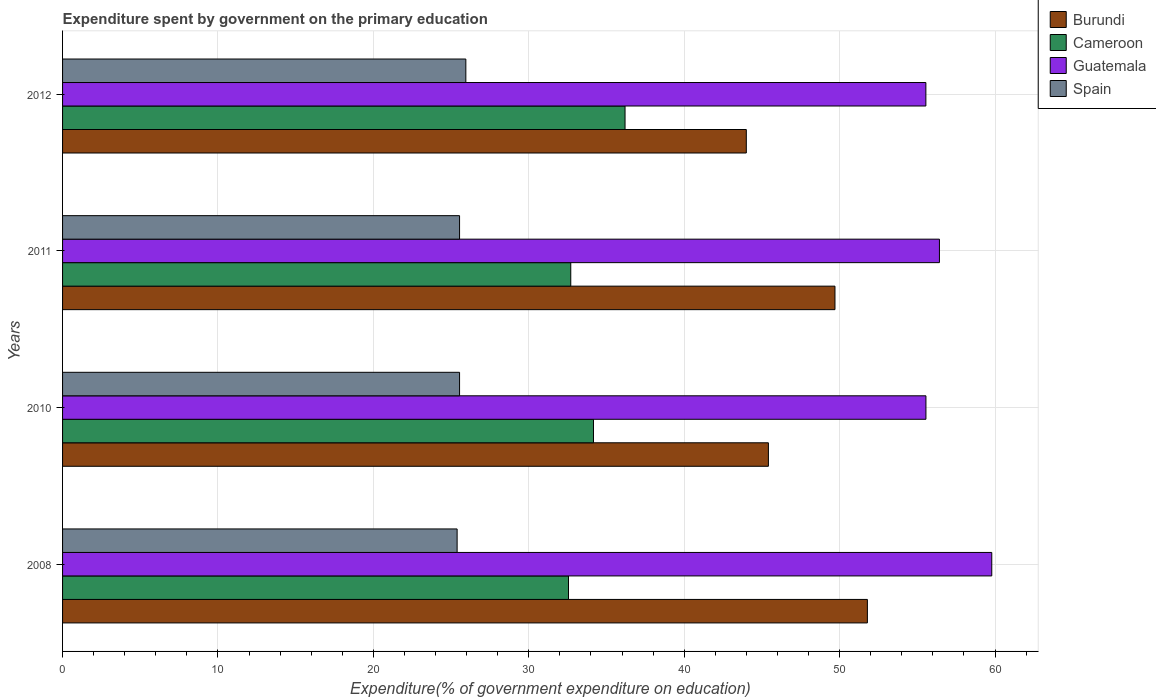How many different coloured bars are there?
Ensure brevity in your answer.  4. Are the number of bars per tick equal to the number of legend labels?
Make the answer very short. Yes. Are the number of bars on each tick of the Y-axis equal?
Ensure brevity in your answer.  Yes. How many bars are there on the 3rd tick from the bottom?
Provide a short and direct response. 4. What is the label of the 4th group of bars from the top?
Provide a succinct answer. 2008. What is the expenditure spent by government on the primary education in Guatemala in 2011?
Make the answer very short. 56.42. Across all years, what is the maximum expenditure spent by government on the primary education in Guatemala?
Keep it short and to the point. 59.79. Across all years, what is the minimum expenditure spent by government on the primary education in Burundi?
Provide a succinct answer. 44. In which year was the expenditure spent by government on the primary education in Cameroon maximum?
Ensure brevity in your answer.  2012. What is the total expenditure spent by government on the primary education in Guatemala in the graph?
Provide a succinct answer. 227.32. What is the difference between the expenditure spent by government on the primary education in Spain in 2011 and that in 2012?
Make the answer very short. -0.4. What is the difference between the expenditure spent by government on the primary education in Guatemala in 2011 and the expenditure spent by government on the primary education in Burundi in 2008?
Your answer should be compact. 4.64. What is the average expenditure spent by government on the primary education in Spain per year?
Your answer should be compact. 25.61. In the year 2011, what is the difference between the expenditure spent by government on the primary education in Burundi and expenditure spent by government on the primary education in Spain?
Your answer should be compact. 24.16. In how many years, is the expenditure spent by government on the primary education in Spain greater than 22 %?
Your answer should be very brief. 4. What is the ratio of the expenditure spent by government on the primary education in Guatemala in 2011 to that in 2012?
Make the answer very short. 1.02. What is the difference between the highest and the second highest expenditure spent by government on the primary education in Guatemala?
Keep it short and to the point. 3.37. What is the difference between the highest and the lowest expenditure spent by government on the primary education in Guatemala?
Keep it short and to the point. 4.24. Is it the case that in every year, the sum of the expenditure spent by government on the primary education in Cameroon and expenditure spent by government on the primary education in Guatemala is greater than the sum of expenditure spent by government on the primary education in Spain and expenditure spent by government on the primary education in Burundi?
Provide a succinct answer. Yes. What does the 1st bar from the top in 2010 represents?
Offer a very short reply. Spain. What does the 3rd bar from the bottom in 2011 represents?
Your answer should be very brief. Guatemala. What is the difference between two consecutive major ticks on the X-axis?
Your answer should be very brief. 10. Are the values on the major ticks of X-axis written in scientific E-notation?
Keep it short and to the point. No. Where does the legend appear in the graph?
Your response must be concise. Top right. How many legend labels are there?
Provide a short and direct response. 4. What is the title of the graph?
Provide a short and direct response. Expenditure spent by government on the primary education. Does "Virgin Islands" appear as one of the legend labels in the graph?
Your answer should be compact. No. What is the label or title of the X-axis?
Provide a short and direct response. Expenditure(% of government expenditure on education). What is the Expenditure(% of government expenditure on education) in Burundi in 2008?
Keep it short and to the point. 51.79. What is the Expenditure(% of government expenditure on education) of Cameroon in 2008?
Offer a very short reply. 32.55. What is the Expenditure(% of government expenditure on education) of Guatemala in 2008?
Your answer should be compact. 59.79. What is the Expenditure(% of government expenditure on education) in Spain in 2008?
Your response must be concise. 25.39. What is the Expenditure(% of government expenditure on education) of Burundi in 2010?
Your answer should be compact. 45.42. What is the Expenditure(% of government expenditure on education) of Cameroon in 2010?
Your answer should be very brief. 34.16. What is the Expenditure(% of government expenditure on education) of Guatemala in 2010?
Provide a succinct answer. 55.55. What is the Expenditure(% of government expenditure on education) in Spain in 2010?
Your response must be concise. 25.54. What is the Expenditure(% of government expenditure on education) of Burundi in 2011?
Your answer should be very brief. 49.7. What is the Expenditure(% of government expenditure on education) in Cameroon in 2011?
Your answer should be very brief. 32.7. What is the Expenditure(% of government expenditure on education) in Guatemala in 2011?
Offer a terse response. 56.42. What is the Expenditure(% of government expenditure on education) in Spain in 2011?
Ensure brevity in your answer.  25.54. What is the Expenditure(% of government expenditure on education) in Burundi in 2012?
Give a very brief answer. 44. What is the Expenditure(% of government expenditure on education) of Cameroon in 2012?
Give a very brief answer. 36.19. What is the Expenditure(% of government expenditure on education) of Guatemala in 2012?
Your answer should be compact. 55.55. What is the Expenditure(% of government expenditure on education) of Spain in 2012?
Your answer should be compact. 25.95. Across all years, what is the maximum Expenditure(% of government expenditure on education) of Burundi?
Provide a short and direct response. 51.79. Across all years, what is the maximum Expenditure(% of government expenditure on education) of Cameroon?
Your answer should be compact. 36.19. Across all years, what is the maximum Expenditure(% of government expenditure on education) of Guatemala?
Provide a succinct answer. 59.79. Across all years, what is the maximum Expenditure(% of government expenditure on education) in Spain?
Your answer should be very brief. 25.95. Across all years, what is the minimum Expenditure(% of government expenditure on education) in Burundi?
Make the answer very short. 44. Across all years, what is the minimum Expenditure(% of government expenditure on education) in Cameroon?
Make the answer very short. 32.55. Across all years, what is the minimum Expenditure(% of government expenditure on education) in Guatemala?
Provide a succinct answer. 55.55. Across all years, what is the minimum Expenditure(% of government expenditure on education) in Spain?
Provide a short and direct response. 25.39. What is the total Expenditure(% of government expenditure on education) of Burundi in the graph?
Give a very brief answer. 190.9. What is the total Expenditure(% of government expenditure on education) in Cameroon in the graph?
Offer a terse response. 135.61. What is the total Expenditure(% of government expenditure on education) of Guatemala in the graph?
Make the answer very short. 227.32. What is the total Expenditure(% of government expenditure on education) in Spain in the graph?
Your answer should be compact. 102.43. What is the difference between the Expenditure(% of government expenditure on education) in Burundi in 2008 and that in 2010?
Give a very brief answer. 6.37. What is the difference between the Expenditure(% of government expenditure on education) in Cameroon in 2008 and that in 2010?
Make the answer very short. -1.61. What is the difference between the Expenditure(% of government expenditure on education) of Guatemala in 2008 and that in 2010?
Your response must be concise. 4.24. What is the difference between the Expenditure(% of government expenditure on education) of Spain in 2008 and that in 2010?
Your answer should be very brief. -0.16. What is the difference between the Expenditure(% of government expenditure on education) of Burundi in 2008 and that in 2011?
Make the answer very short. 2.09. What is the difference between the Expenditure(% of government expenditure on education) of Cameroon in 2008 and that in 2011?
Keep it short and to the point. -0.15. What is the difference between the Expenditure(% of government expenditure on education) of Guatemala in 2008 and that in 2011?
Provide a short and direct response. 3.37. What is the difference between the Expenditure(% of government expenditure on education) of Spain in 2008 and that in 2011?
Your response must be concise. -0.16. What is the difference between the Expenditure(% of government expenditure on education) of Burundi in 2008 and that in 2012?
Your response must be concise. 7.79. What is the difference between the Expenditure(% of government expenditure on education) in Cameroon in 2008 and that in 2012?
Your answer should be compact. -3.64. What is the difference between the Expenditure(% of government expenditure on education) in Guatemala in 2008 and that in 2012?
Your response must be concise. 4.24. What is the difference between the Expenditure(% of government expenditure on education) of Spain in 2008 and that in 2012?
Your answer should be compact. -0.56. What is the difference between the Expenditure(% of government expenditure on education) of Burundi in 2010 and that in 2011?
Offer a very short reply. -4.28. What is the difference between the Expenditure(% of government expenditure on education) in Cameroon in 2010 and that in 2011?
Give a very brief answer. 1.46. What is the difference between the Expenditure(% of government expenditure on education) of Guatemala in 2010 and that in 2011?
Offer a terse response. -0.87. What is the difference between the Expenditure(% of government expenditure on education) in Spain in 2010 and that in 2011?
Ensure brevity in your answer.  0. What is the difference between the Expenditure(% of government expenditure on education) of Burundi in 2010 and that in 2012?
Your response must be concise. 1.42. What is the difference between the Expenditure(% of government expenditure on education) in Cameroon in 2010 and that in 2012?
Your answer should be very brief. -2.03. What is the difference between the Expenditure(% of government expenditure on education) of Guatemala in 2010 and that in 2012?
Your answer should be compact. 0. What is the difference between the Expenditure(% of government expenditure on education) of Spain in 2010 and that in 2012?
Ensure brevity in your answer.  -0.4. What is the difference between the Expenditure(% of government expenditure on education) of Burundi in 2011 and that in 2012?
Offer a terse response. 5.7. What is the difference between the Expenditure(% of government expenditure on education) of Cameroon in 2011 and that in 2012?
Make the answer very short. -3.49. What is the difference between the Expenditure(% of government expenditure on education) in Guatemala in 2011 and that in 2012?
Provide a succinct answer. 0.87. What is the difference between the Expenditure(% of government expenditure on education) of Spain in 2011 and that in 2012?
Your response must be concise. -0.4. What is the difference between the Expenditure(% of government expenditure on education) in Burundi in 2008 and the Expenditure(% of government expenditure on education) in Cameroon in 2010?
Offer a very short reply. 17.63. What is the difference between the Expenditure(% of government expenditure on education) of Burundi in 2008 and the Expenditure(% of government expenditure on education) of Guatemala in 2010?
Offer a terse response. -3.77. What is the difference between the Expenditure(% of government expenditure on education) of Burundi in 2008 and the Expenditure(% of government expenditure on education) of Spain in 2010?
Your answer should be very brief. 26.24. What is the difference between the Expenditure(% of government expenditure on education) of Cameroon in 2008 and the Expenditure(% of government expenditure on education) of Guatemala in 2010?
Your answer should be compact. -23. What is the difference between the Expenditure(% of government expenditure on education) of Cameroon in 2008 and the Expenditure(% of government expenditure on education) of Spain in 2010?
Make the answer very short. 7.01. What is the difference between the Expenditure(% of government expenditure on education) in Guatemala in 2008 and the Expenditure(% of government expenditure on education) in Spain in 2010?
Provide a succinct answer. 34.25. What is the difference between the Expenditure(% of government expenditure on education) of Burundi in 2008 and the Expenditure(% of government expenditure on education) of Cameroon in 2011?
Your answer should be very brief. 19.09. What is the difference between the Expenditure(% of government expenditure on education) in Burundi in 2008 and the Expenditure(% of government expenditure on education) in Guatemala in 2011?
Make the answer very short. -4.64. What is the difference between the Expenditure(% of government expenditure on education) of Burundi in 2008 and the Expenditure(% of government expenditure on education) of Spain in 2011?
Your answer should be compact. 26.24. What is the difference between the Expenditure(% of government expenditure on education) of Cameroon in 2008 and the Expenditure(% of government expenditure on education) of Guatemala in 2011?
Your response must be concise. -23.87. What is the difference between the Expenditure(% of government expenditure on education) in Cameroon in 2008 and the Expenditure(% of government expenditure on education) in Spain in 2011?
Provide a short and direct response. 7.01. What is the difference between the Expenditure(% of government expenditure on education) in Guatemala in 2008 and the Expenditure(% of government expenditure on education) in Spain in 2011?
Ensure brevity in your answer.  34.25. What is the difference between the Expenditure(% of government expenditure on education) of Burundi in 2008 and the Expenditure(% of government expenditure on education) of Cameroon in 2012?
Make the answer very short. 15.59. What is the difference between the Expenditure(% of government expenditure on education) of Burundi in 2008 and the Expenditure(% of government expenditure on education) of Guatemala in 2012?
Your answer should be very brief. -3.76. What is the difference between the Expenditure(% of government expenditure on education) of Burundi in 2008 and the Expenditure(% of government expenditure on education) of Spain in 2012?
Provide a short and direct response. 25.84. What is the difference between the Expenditure(% of government expenditure on education) in Cameroon in 2008 and the Expenditure(% of government expenditure on education) in Guatemala in 2012?
Your response must be concise. -23. What is the difference between the Expenditure(% of government expenditure on education) in Cameroon in 2008 and the Expenditure(% of government expenditure on education) in Spain in 2012?
Offer a terse response. 6.61. What is the difference between the Expenditure(% of government expenditure on education) in Guatemala in 2008 and the Expenditure(% of government expenditure on education) in Spain in 2012?
Make the answer very short. 33.84. What is the difference between the Expenditure(% of government expenditure on education) in Burundi in 2010 and the Expenditure(% of government expenditure on education) in Cameroon in 2011?
Your answer should be very brief. 12.72. What is the difference between the Expenditure(% of government expenditure on education) in Burundi in 2010 and the Expenditure(% of government expenditure on education) in Guatemala in 2011?
Ensure brevity in your answer.  -11. What is the difference between the Expenditure(% of government expenditure on education) of Burundi in 2010 and the Expenditure(% of government expenditure on education) of Spain in 2011?
Provide a succinct answer. 19.87. What is the difference between the Expenditure(% of government expenditure on education) in Cameroon in 2010 and the Expenditure(% of government expenditure on education) in Guatemala in 2011?
Provide a succinct answer. -22.26. What is the difference between the Expenditure(% of government expenditure on education) in Cameroon in 2010 and the Expenditure(% of government expenditure on education) in Spain in 2011?
Offer a terse response. 8.62. What is the difference between the Expenditure(% of government expenditure on education) of Guatemala in 2010 and the Expenditure(% of government expenditure on education) of Spain in 2011?
Your response must be concise. 30.01. What is the difference between the Expenditure(% of government expenditure on education) of Burundi in 2010 and the Expenditure(% of government expenditure on education) of Cameroon in 2012?
Keep it short and to the point. 9.22. What is the difference between the Expenditure(% of government expenditure on education) of Burundi in 2010 and the Expenditure(% of government expenditure on education) of Guatemala in 2012?
Ensure brevity in your answer.  -10.13. What is the difference between the Expenditure(% of government expenditure on education) of Burundi in 2010 and the Expenditure(% of government expenditure on education) of Spain in 2012?
Ensure brevity in your answer.  19.47. What is the difference between the Expenditure(% of government expenditure on education) in Cameroon in 2010 and the Expenditure(% of government expenditure on education) in Guatemala in 2012?
Your answer should be very brief. -21.39. What is the difference between the Expenditure(% of government expenditure on education) in Cameroon in 2010 and the Expenditure(% of government expenditure on education) in Spain in 2012?
Offer a terse response. 8.21. What is the difference between the Expenditure(% of government expenditure on education) of Guatemala in 2010 and the Expenditure(% of government expenditure on education) of Spain in 2012?
Keep it short and to the point. 29.6. What is the difference between the Expenditure(% of government expenditure on education) of Burundi in 2011 and the Expenditure(% of government expenditure on education) of Cameroon in 2012?
Provide a short and direct response. 13.51. What is the difference between the Expenditure(% of government expenditure on education) in Burundi in 2011 and the Expenditure(% of government expenditure on education) in Guatemala in 2012?
Your response must be concise. -5.85. What is the difference between the Expenditure(% of government expenditure on education) of Burundi in 2011 and the Expenditure(% of government expenditure on education) of Spain in 2012?
Offer a terse response. 23.75. What is the difference between the Expenditure(% of government expenditure on education) of Cameroon in 2011 and the Expenditure(% of government expenditure on education) of Guatemala in 2012?
Your answer should be compact. -22.85. What is the difference between the Expenditure(% of government expenditure on education) of Cameroon in 2011 and the Expenditure(% of government expenditure on education) of Spain in 2012?
Offer a terse response. 6.75. What is the difference between the Expenditure(% of government expenditure on education) of Guatemala in 2011 and the Expenditure(% of government expenditure on education) of Spain in 2012?
Make the answer very short. 30.47. What is the average Expenditure(% of government expenditure on education) of Burundi per year?
Keep it short and to the point. 47.73. What is the average Expenditure(% of government expenditure on education) of Cameroon per year?
Ensure brevity in your answer.  33.9. What is the average Expenditure(% of government expenditure on education) of Guatemala per year?
Your response must be concise. 56.83. What is the average Expenditure(% of government expenditure on education) in Spain per year?
Ensure brevity in your answer.  25.61. In the year 2008, what is the difference between the Expenditure(% of government expenditure on education) of Burundi and Expenditure(% of government expenditure on education) of Cameroon?
Ensure brevity in your answer.  19.23. In the year 2008, what is the difference between the Expenditure(% of government expenditure on education) of Burundi and Expenditure(% of government expenditure on education) of Guatemala?
Ensure brevity in your answer.  -8. In the year 2008, what is the difference between the Expenditure(% of government expenditure on education) in Burundi and Expenditure(% of government expenditure on education) in Spain?
Offer a very short reply. 26.4. In the year 2008, what is the difference between the Expenditure(% of government expenditure on education) of Cameroon and Expenditure(% of government expenditure on education) of Guatemala?
Provide a succinct answer. -27.24. In the year 2008, what is the difference between the Expenditure(% of government expenditure on education) of Cameroon and Expenditure(% of government expenditure on education) of Spain?
Make the answer very short. 7.17. In the year 2008, what is the difference between the Expenditure(% of government expenditure on education) of Guatemala and Expenditure(% of government expenditure on education) of Spain?
Make the answer very short. 34.4. In the year 2010, what is the difference between the Expenditure(% of government expenditure on education) of Burundi and Expenditure(% of government expenditure on education) of Cameroon?
Your answer should be compact. 11.26. In the year 2010, what is the difference between the Expenditure(% of government expenditure on education) in Burundi and Expenditure(% of government expenditure on education) in Guatemala?
Provide a succinct answer. -10.14. In the year 2010, what is the difference between the Expenditure(% of government expenditure on education) in Burundi and Expenditure(% of government expenditure on education) in Spain?
Make the answer very short. 19.87. In the year 2010, what is the difference between the Expenditure(% of government expenditure on education) of Cameroon and Expenditure(% of government expenditure on education) of Guatemala?
Your answer should be compact. -21.39. In the year 2010, what is the difference between the Expenditure(% of government expenditure on education) in Cameroon and Expenditure(% of government expenditure on education) in Spain?
Keep it short and to the point. 8.62. In the year 2010, what is the difference between the Expenditure(% of government expenditure on education) in Guatemala and Expenditure(% of government expenditure on education) in Spain?
Your answer should be compact. 30.01. In the year 2011, what is the difference between the Expenditure(% of government expenditure on education) of Burundi and Expenditure(% of government expenditure on education) of Cameroon?
Keep it short and to the point. 17. In the year 2011, what is the difference between the Expenditure(% of government expenditure on education) in Burundi and Expenditure(% of government expenditure on education) in Guatemala?
Your response must be concise. -6.72. In the year 2011, what is the difference between the Expenditure(% of government expenditure on education) in Burundi and Expenditure(% of government expenditure on education) in Spain?
Your response must be concise. 24.16. In the year 2011, what is the difference between the Expenditure(% of government expenditure on education) of Cameroon and Expenditure(% of government expenditure on education) of Guatemala?
Keep it short and to the point. -23.72. In the year 2011, what is the difference between the Expenditure(% of government expenditure on education) in Cameroon and Expenditure(% of government expenditure on education) in Spain?
Give a very brief answer. 7.16. In the year 2011, what is the difference between the Expenditure(% of government expenditure on education) in Guatemala and Expenditure(% of government expenditure on education) in Spain?
Keep it short and to the point. 30.88. In the year 2012, what is the difference between the Expenditure(% of government expenditure on education) of Burundi and Expenditure(% of government expenditure on education) of Cameroon?
Provide a short and direct response. 7.8. In the year 2012, what is the difference between the Expenditure(% of government expenditure on education) of Burundi and Expenditure(% of government expenditure on education) of Guatemala?
Offer a terse response. -11.55. In the year 2012, what is the difference between the Expenditure(% of government expenditure on education) in Burundi and Expenditure(% of government expenditure on education) in Spain?
Keep it short and to the point. 18.05. In the year 2012, what is the difference between the Expenditure(% of government expenditure on education) of Cameroon and Expenditure(% of government expenditure on education) of Guatemala?
Give a very brief answer. -19.36. In the year 2012, what is the difference between the Expenditure(% of government expenditure on education) in Cameroon and Expenditure(% of government expenditure on education) in Spain?
Provide a succinct answer. 10.24. In the year 2012, what is the difference between the Expenditure(% of government expenditure on education) in Guatemala and Expenditure(% of government expenditure on education) in Spain?
Give a very brief answer. 29.6. What is the ratio of the Expenditure(% of government expenditure on education) of Burundi in 2008 to that in 2010?
Provide a short and direct response. 1.14. What is the ratio of the Expenditure(% of government expenditure on education) of Cameroon in 2008 to that in 2010?
Provide a short and direct response. 0.95. What is the ratio of the Expenditure(% of government expenditure on education) of Guatemala in 2008 to that in 2010?
Make the answer very short. 1.08. What is the ratio of the Expenditure(% of government expenditure on education) of Spain in 2008 to that in 2010?
Provide a short and direct response. 0.99. What is the ratio of the Expenditure(% of government expenditure on education) in Burundi in 2008 to that in 2011?
Your response must be concise. 1.04. What is the ratio of the Expenditure(% of government expenditure on education) of Cameroon in 2008 to that in 2011?
Your answer should be compact. 1. What is the ratio of the Expenditure(% of government expenditure on education) of Guatemala in 2008 to that in 2011?
Offer a very short reply. 1.06. What is the ratio of the Expenditure(% of government expenditure on education) of Burundi in 2008 to that in 2012?
Offer a terse response. 1.18. What is the ratio of the Expenditure(% of government expenditure on education) in Cameroon in 2008 to that in 2012?
Provide a succinct answer. 0.9. What is the ratio of the Expenditure(% of government expenditure on education) in Guatemala in 2008 to that in 2012?
Give a very brief answer. 1.08. What is the ratio of the Expenditure(% of government expenditure on education) of Spain in 2008 to that in 2012?
Keep it short and to the point. 0.98. What is the ratio of the Expenditure(% of government expenditure on education) of Burundi in 2010 to that in 2011?
Your answer should be very brief. 0.91. What is the ratio of the Expenditure(% of government expenditure on education) of Cameroon in 2010 to that in 2011?
Your answer should be compact. 1.04. What is the ratio of the Expenditure(% of government expenditure on education) in Guatemala in 2010 to that in 2011?
Give a very brief answer. 0.98. What is the ratio of the Expenditure(% of government expenditure on education) in Burundi in 2010 to that in 2012?
Your answer should be very brief. 1.03. What is the ratio of the Expenditure(% of government expenditure on education) of Cameroon in 2010 to that in 2012?
Your answer should be compact. 0.94. What is the ratio of the Expenditure(% of government expenditure on education) in Spain in 2010 to that in 2012?
Make the answer very short. 0.98. What is the ratio of the Expenditure(% of government expenditure on education) in Burundi in 2011 to that in 2012?
Provide a short and direct response. 1.13. What is the ratio of the Expenditure(% of government expenditure on education) in Cameroon in 2011 to that in 2012?
Ensure brevity in your answer.  0.9. What is the ratio of the Expenditure(% of government expenditure on education) in Guatemala in 2011 to that in 2012?
Provide a short and direct response. 1.02. What is the ratio of the Expenditure(% of government expenditure on education) in Spain in 2011 to that in 2012?
Make the answer very short. 0.98. What is the difference between the highest and the second highest Expenditure(% of government expenditure on education) in Burundi?
Make the answer very short. 2.09. What is the difference between the highest and the second highest Expenditure(% of government expenditure on education) in Cameroon?
Offer a very short reply. 2.03. What is the difference between the highest and the second highest Expenditure(% of government expenditure on education) of Guatemala?
Ensure brevity in your answer.  3.37. What is the difference between the highest and the second highest Expenditure(% of government expenditure on education) in Spain?
Give a very brief answer. 0.4. What is the difference between the highest and the lowest Expenditure(% of government expenditure on education) of Burundi?
Offer a very short reply. 7.79. What is the difference between the highest and the lowest Expenditure(% of government expenditure on education) of Cameroon?
Ensure brevity in your answer.  3.64. What is the difference between the highest and the lowest Expenditure(% of government expenditure on education) of Guatemala?
Your answer should be compact. 4.24. What is the difference between the highest and the lowest Expenditure(% of government expenditure on education) in Spain?
Keep it short and to the point. 0.56. 